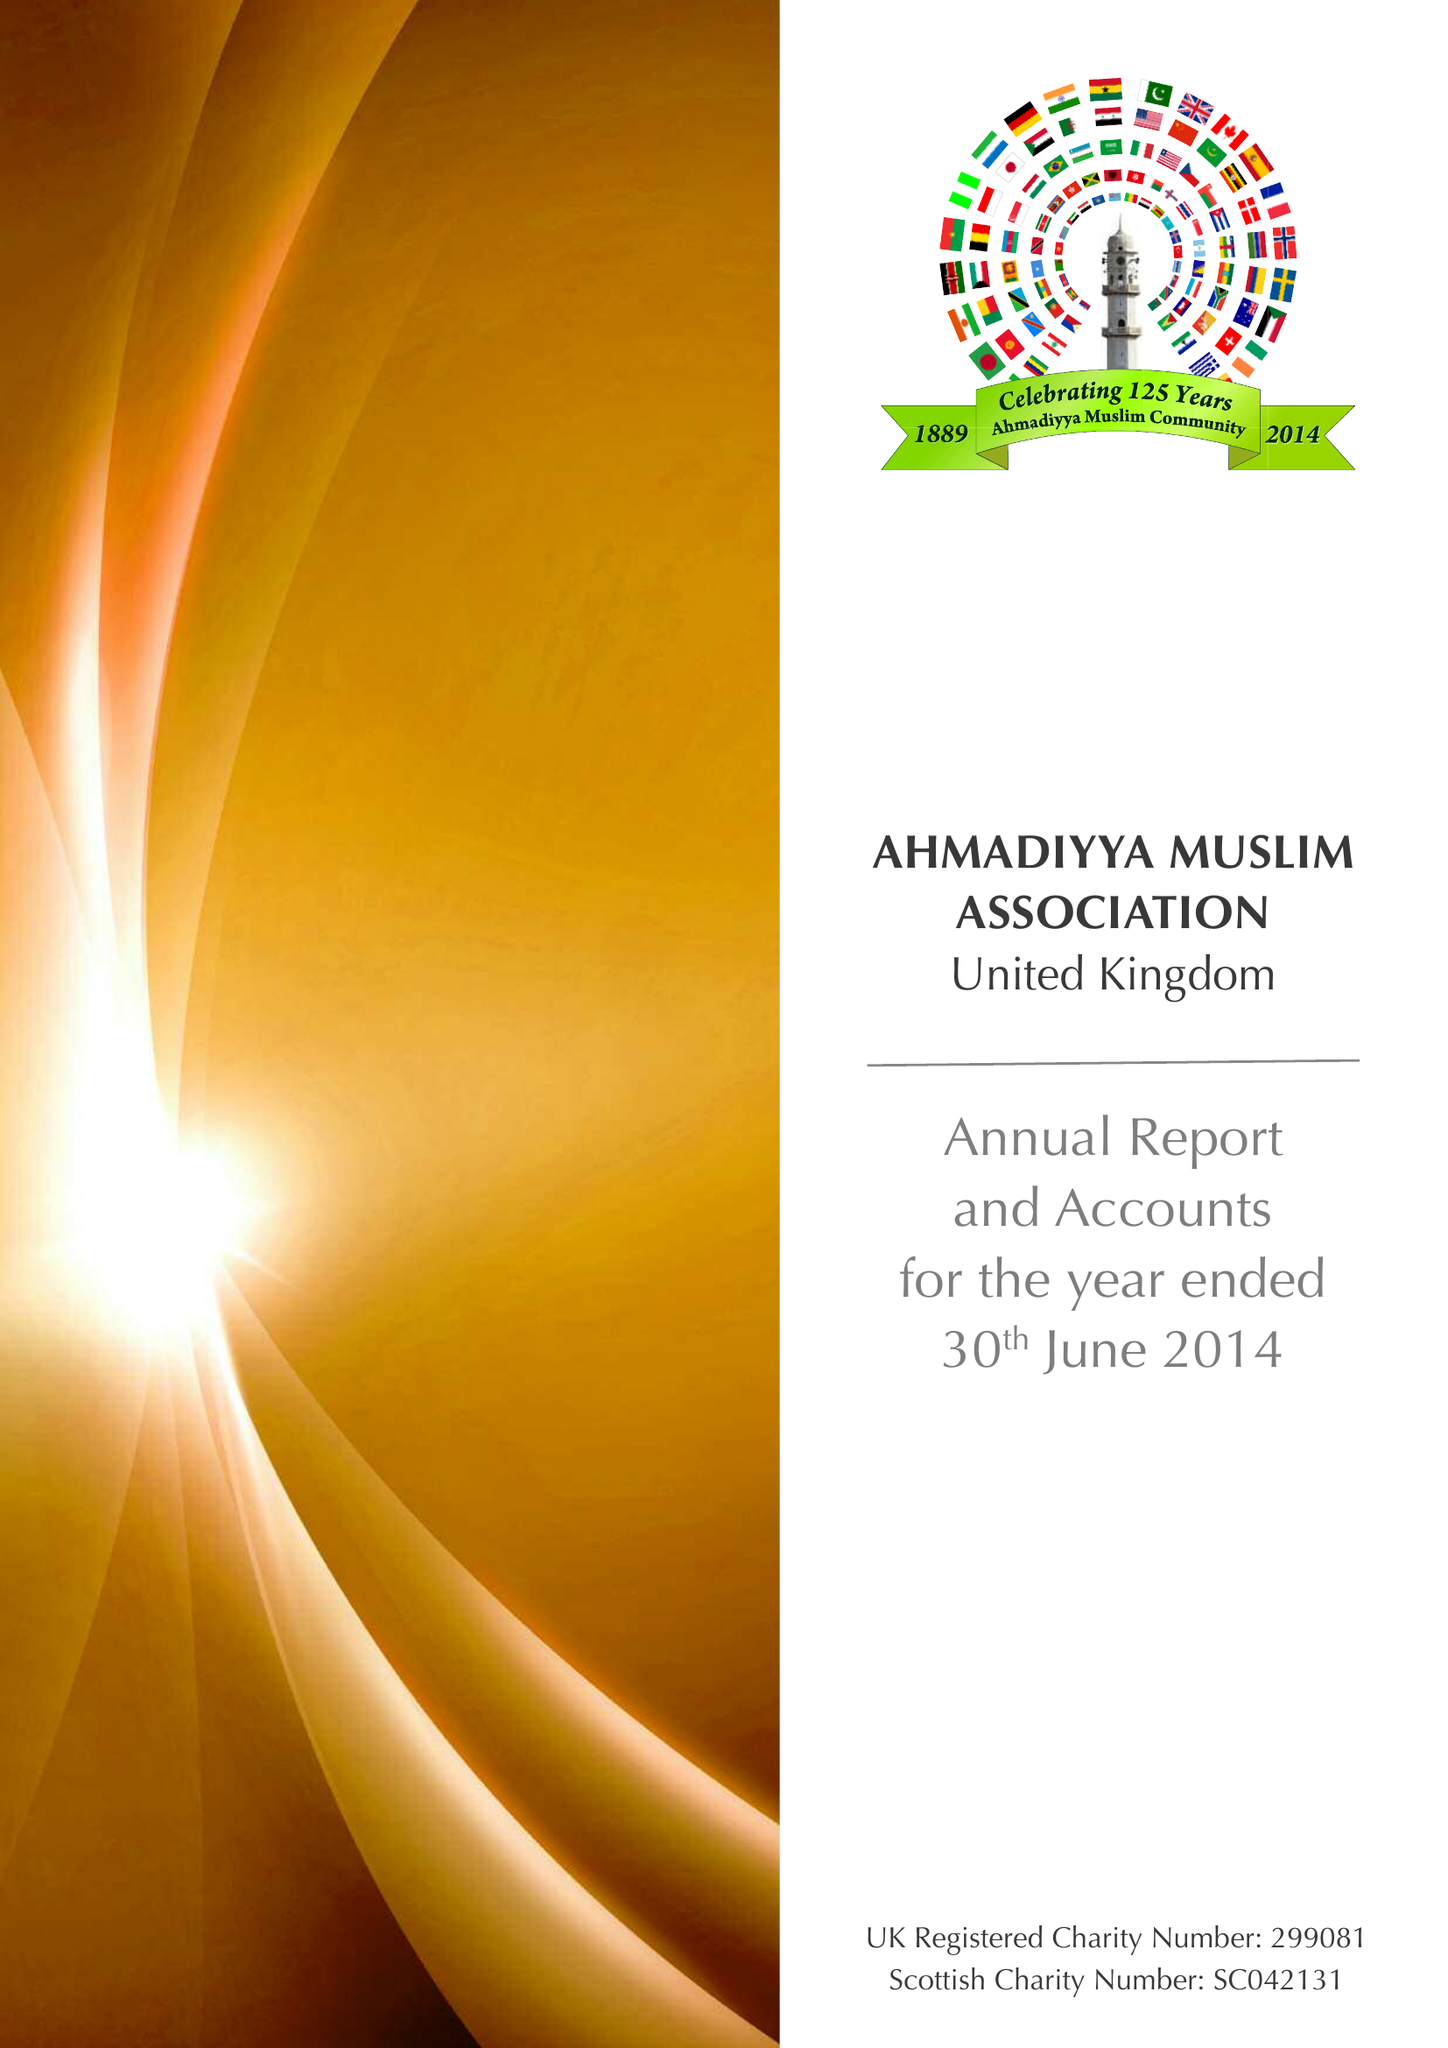What is the value for the address__post_town?
Answer the question using a single word or phrase. LONDON 